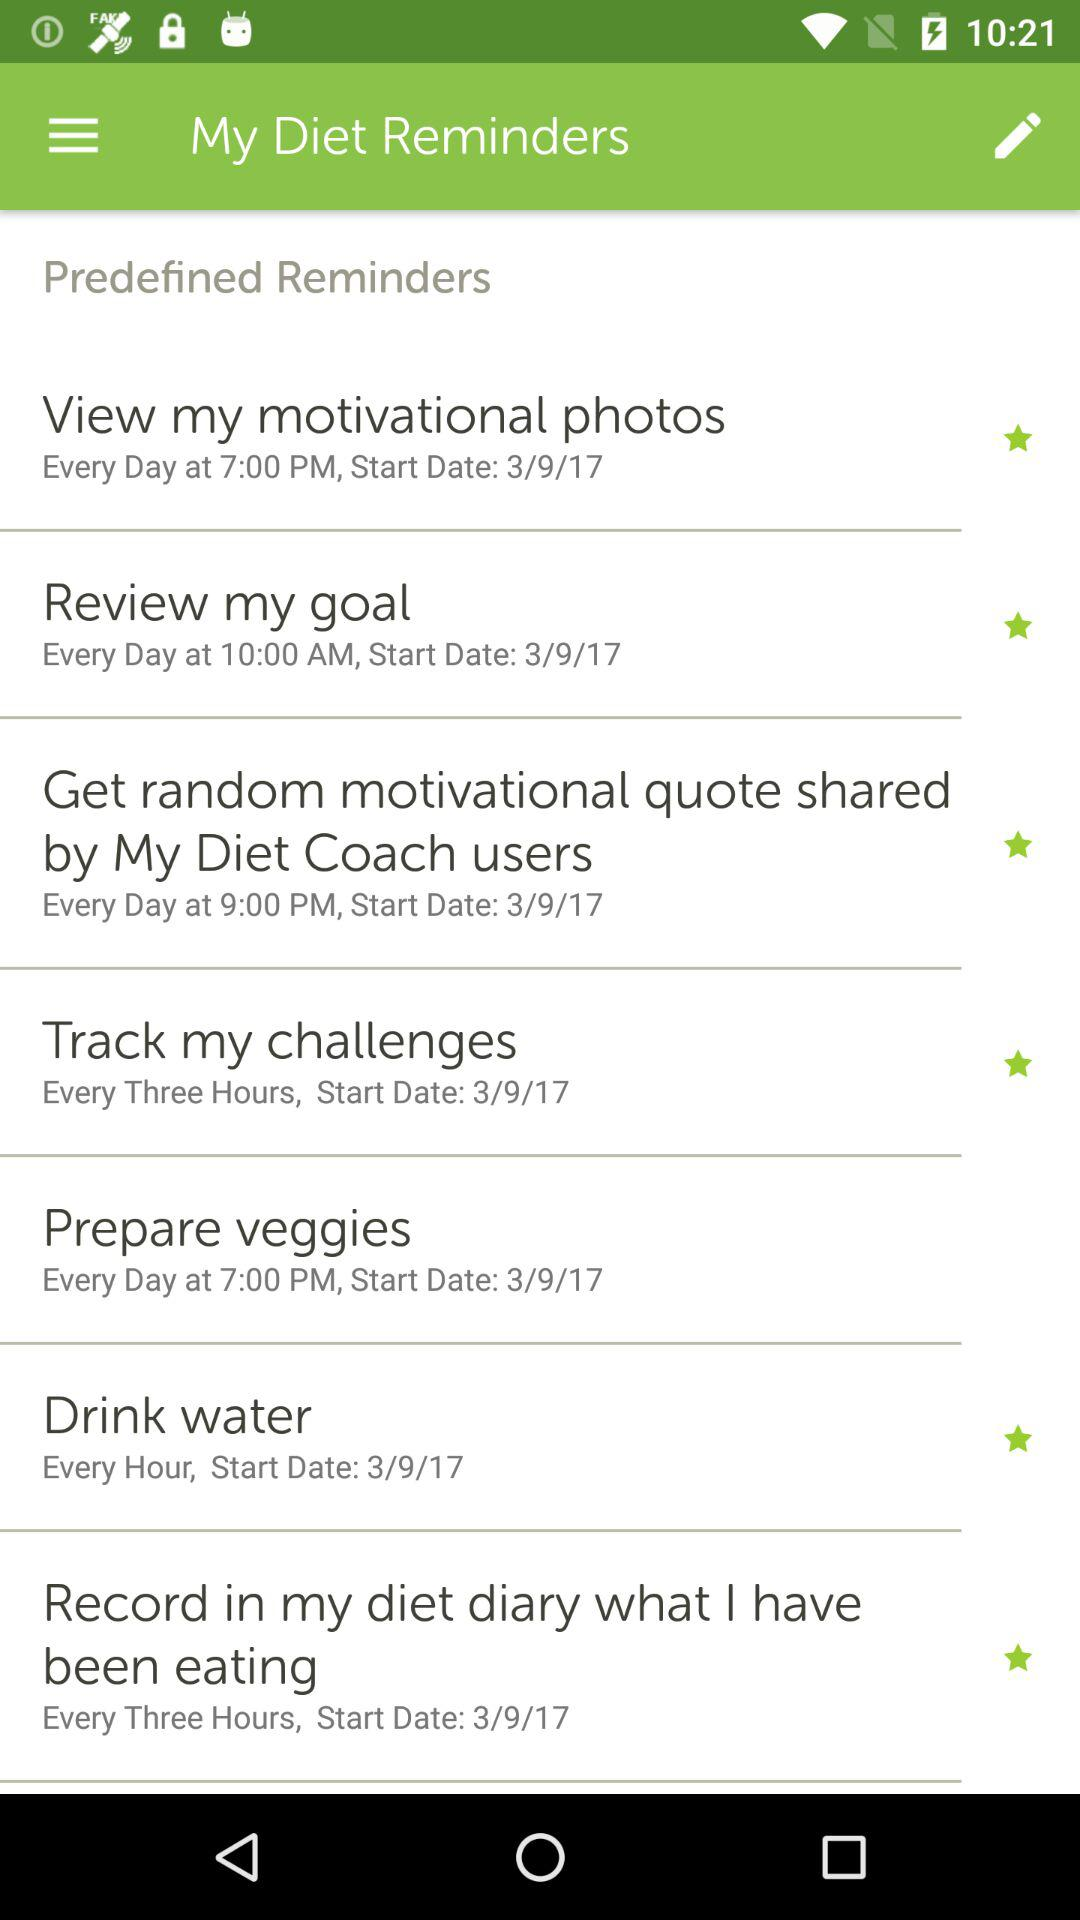What is the start date for drinking water? The start date is 3/9/17. 